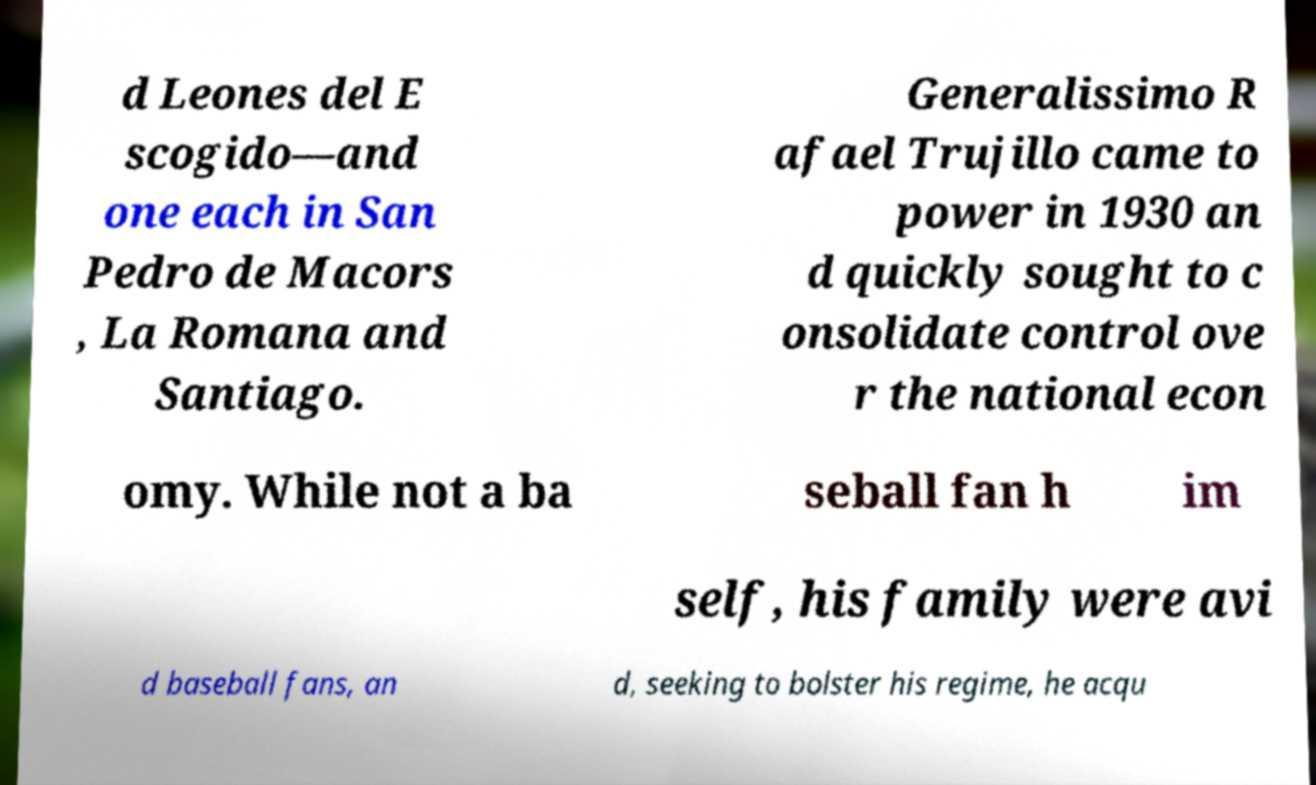Can you accurately transcribe the text from the provided image for me? d Leones del E scogido—and one each in San Pedro de Macors , La Romana and Santiago. Generalissimo R afael Trujillo came to power in 1930 an d quickly sought to c onsolidate control ove r the national econ omy. While not a ba seball fan h im self, his family were avi d baseball fans, an d, seeking to bolster his regime, he acqu 